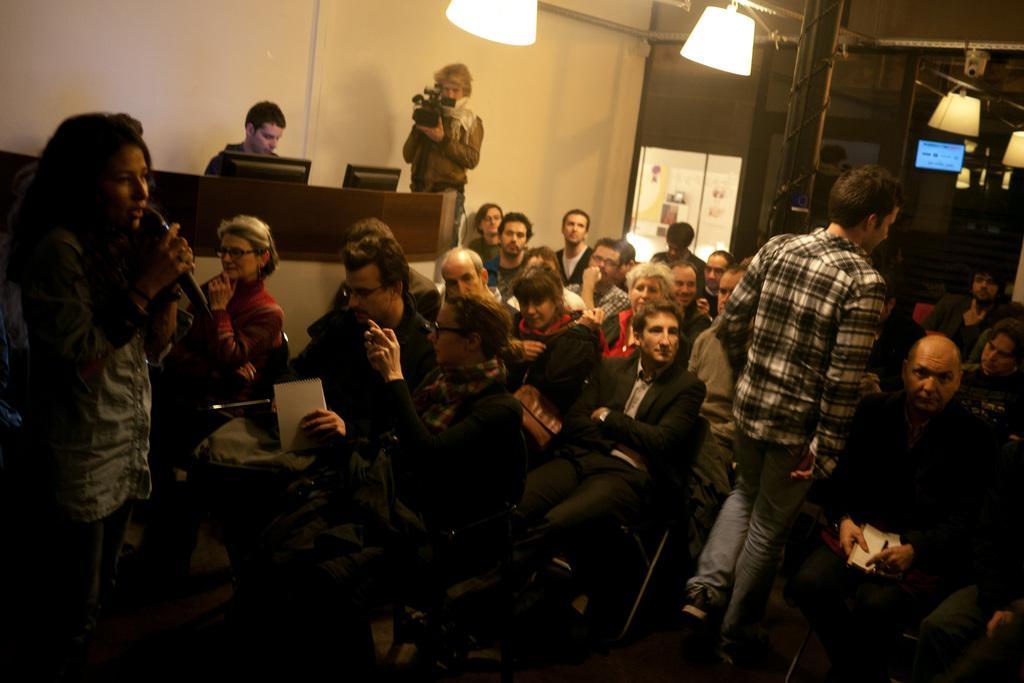Please provide a concise description of this image. In this picture we can see the wall, lights and objects. On the left side of the picture we can see a man standing and holding a camera. We can see people sitting on the chairs. In the middle portion of the picture we can see a man walking on the floor. On the right side of the picture we can see a man sitting on the chair. He is holding a pen and book. On the left side of the picture we can see a woman standing and holding a microphone. 